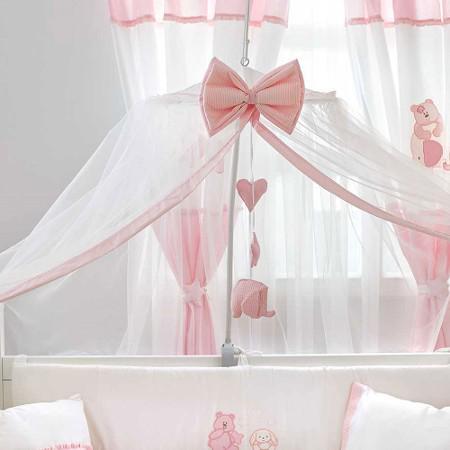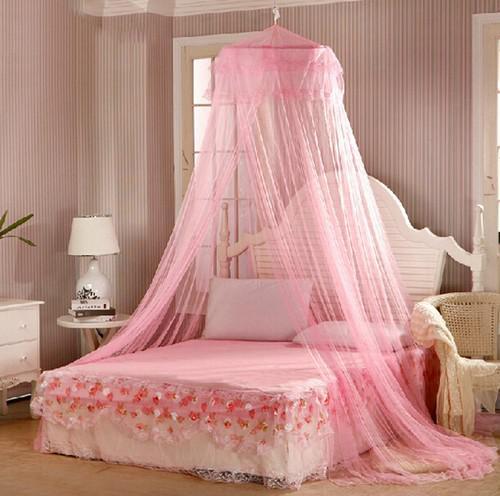The first image is the image on the left, the second image is the image on the right. Evaluate the accuracy of this statement regarding the images: "An image shows a sheer pink canopy that drapes a bed without rails and with an arched headboard from a cone shape suspended from the ceiling.". Is it true? Answer yes or no. Yes. 